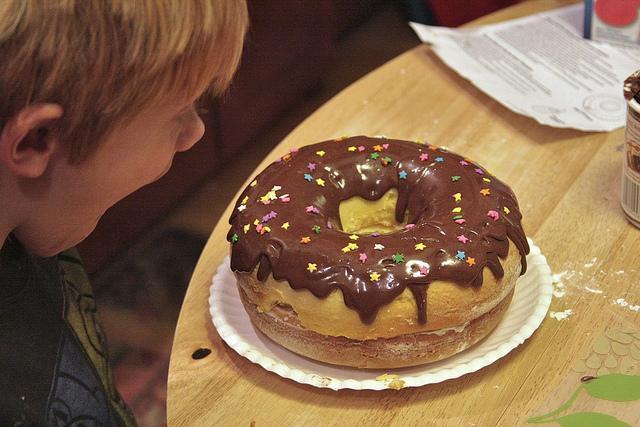How many donuts can be seen?
Give a very brief answer. 1. 